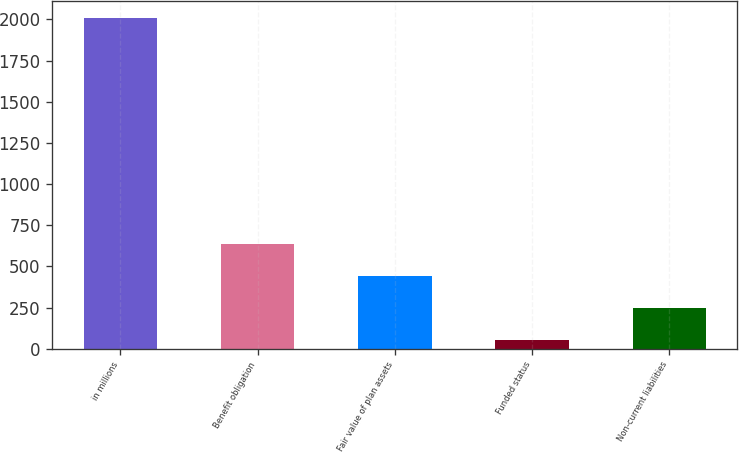<chart> <loc_0><loc_0><loc_500><loc_500><bar_chart><fcel>in millions<fcel>Benefit obligation<fcel>Fair value of plan assets<fcel>Funded status<fcel>Non-current liabilities<nl><fcel>2010<fcel>638.07<fcel>442.08<fcel>50.1<fcel>246.09<nl></chart> 